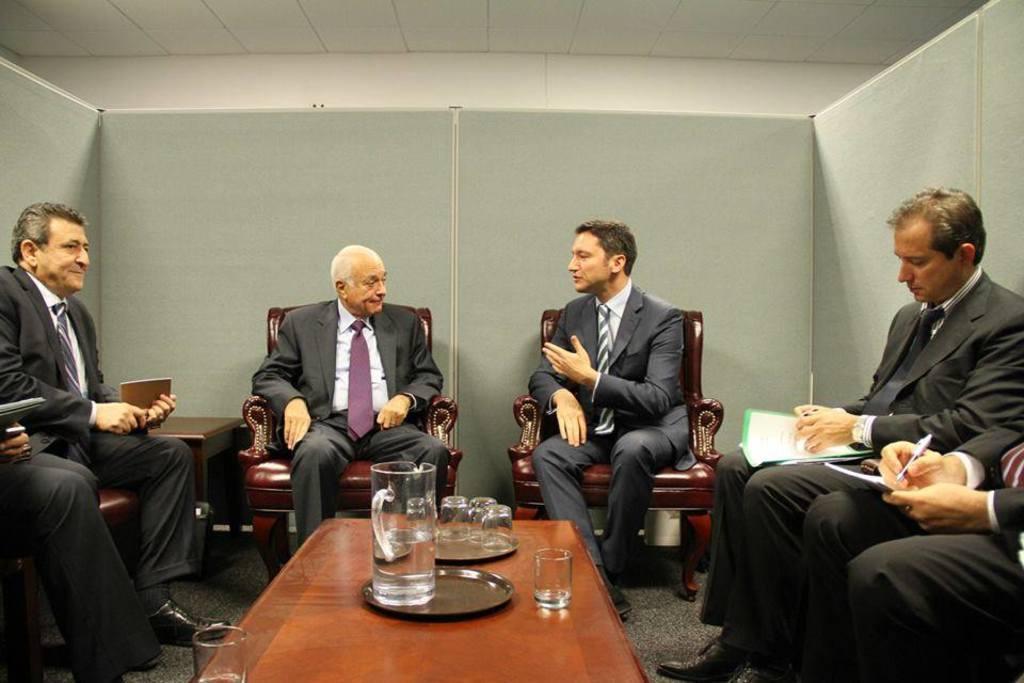How would you summarize this image in a sentence or two? The image is taken in the cabin in the center of the image. There are two people sitting and talking. On the left there is a man sitting on the chair. On the right the people are writing on the notes. In the center there is a table. On the table there are glasses, plates and jug. In the background there is a wall. 